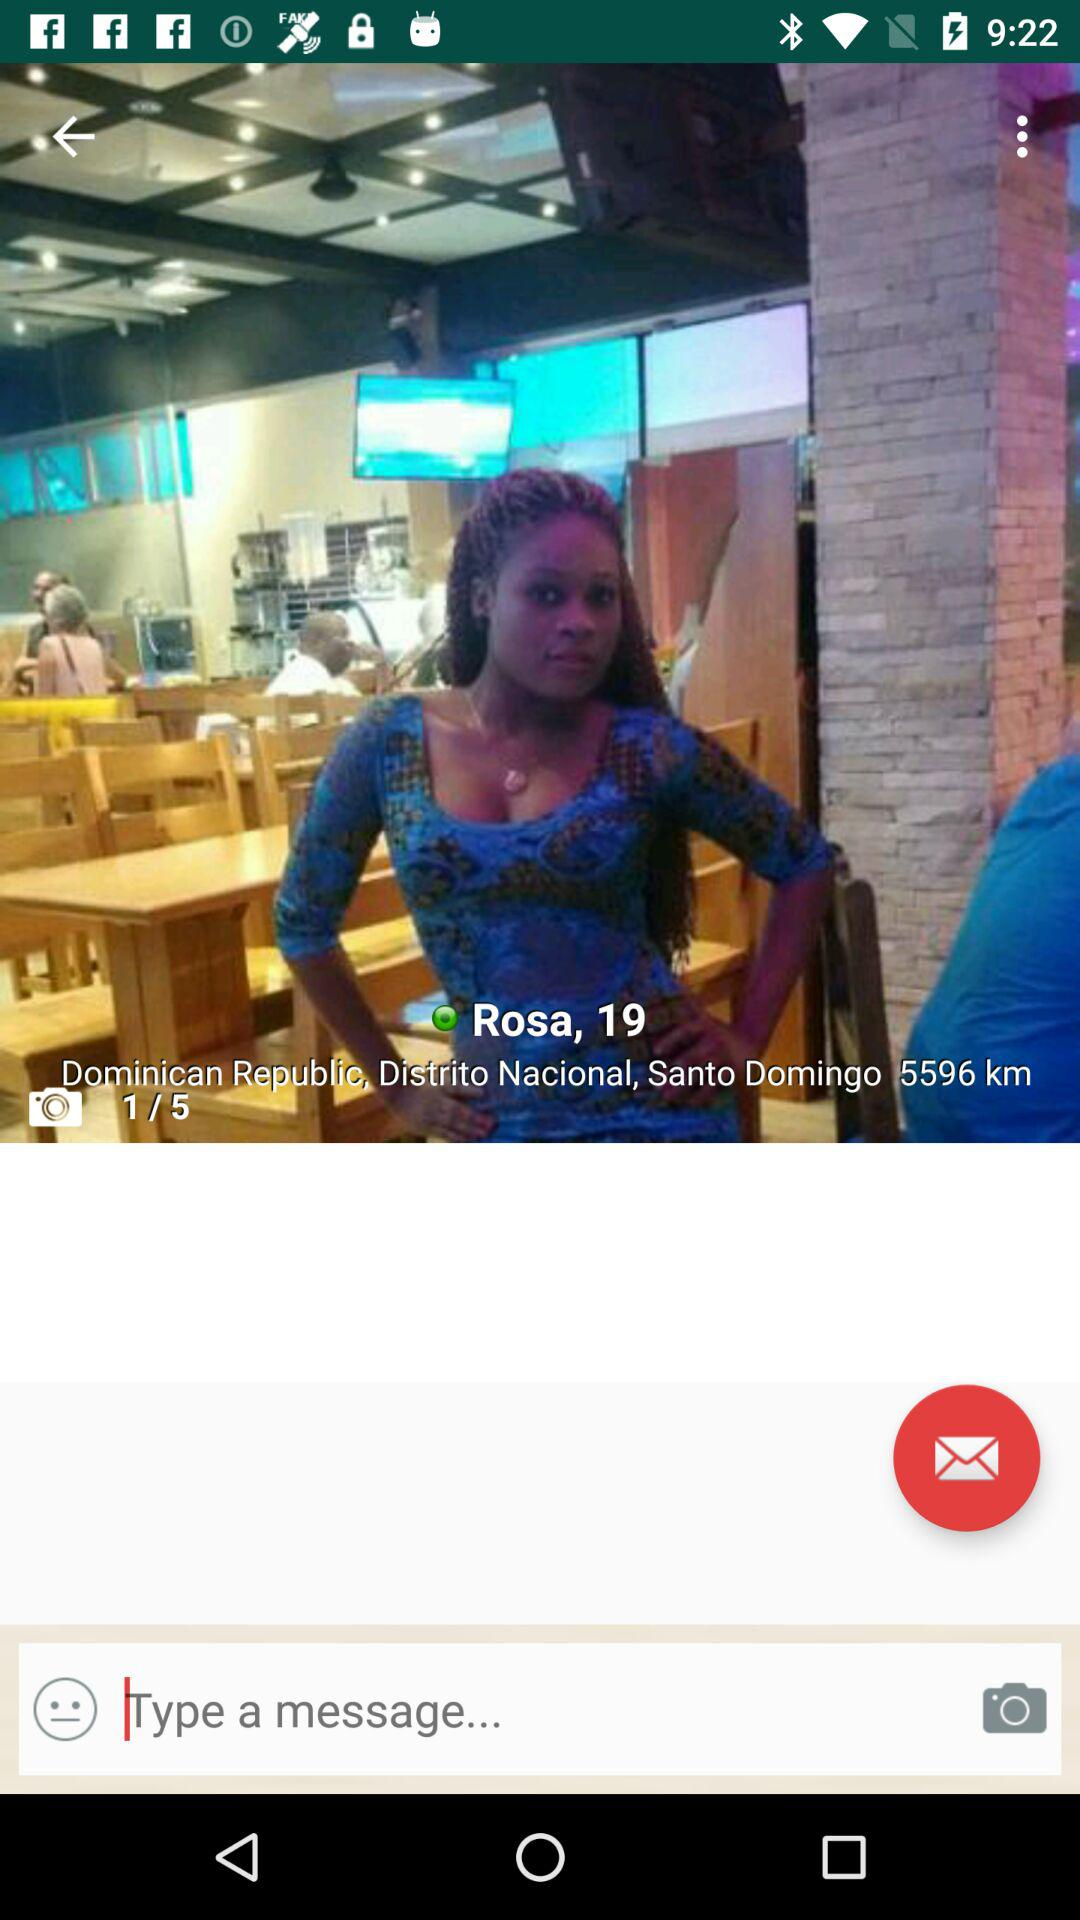What is the address shown on the screen? The address shown on the screen is "Dominican Republic, Distrito Nacional, Santo Domingo". 